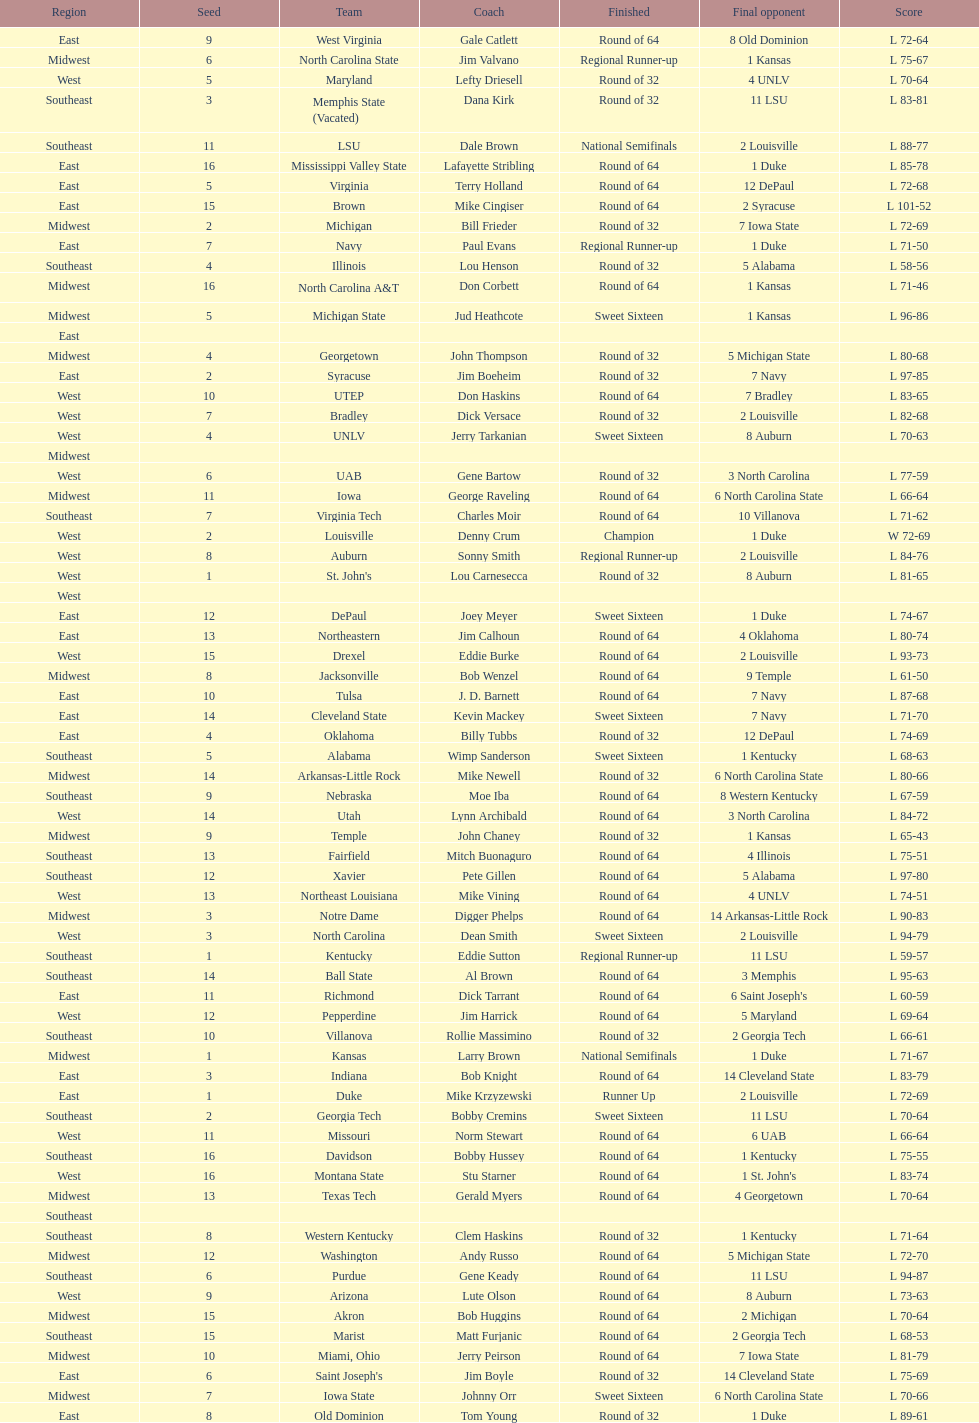Which team went finished later in the tournament, st. john's or north carolina a&t? North Carolina A&T. 